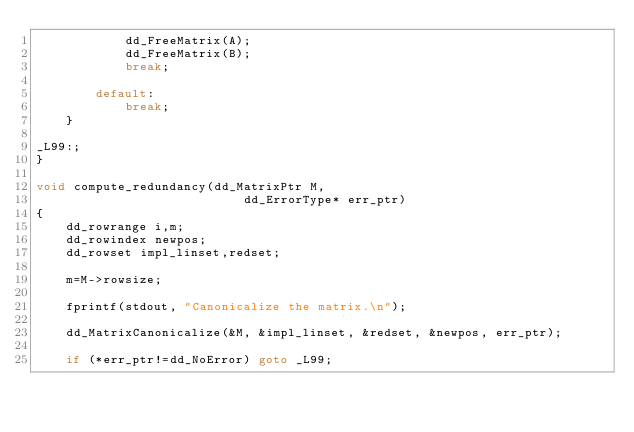Convert code to text. <code><loc_0><loc_0><loc_500><loc_500><_C_>            dd_FreeMatrix(A);
            dd_FreeMatrix(B);
            break;

        default:
            break;
    }

_L99:;
}

void compute_redundancy(dd_MatrixPtr M,
                            dd_ErrorType* err_ptr)
{
    dd_rowrange i,m;
    dd_rowindex newpos;
    dd_rowset impl_linset,redset;

    m=M->rowsize;

    fprintf(stdout, "Canonicalize the matrix.\n");

    dd_MatrixCanonicalize(&M, &impl_linset, &redset, &newpos, err_ptr);

    if (*err_ptr!=dd_NoError) goto _L99;
</code> 